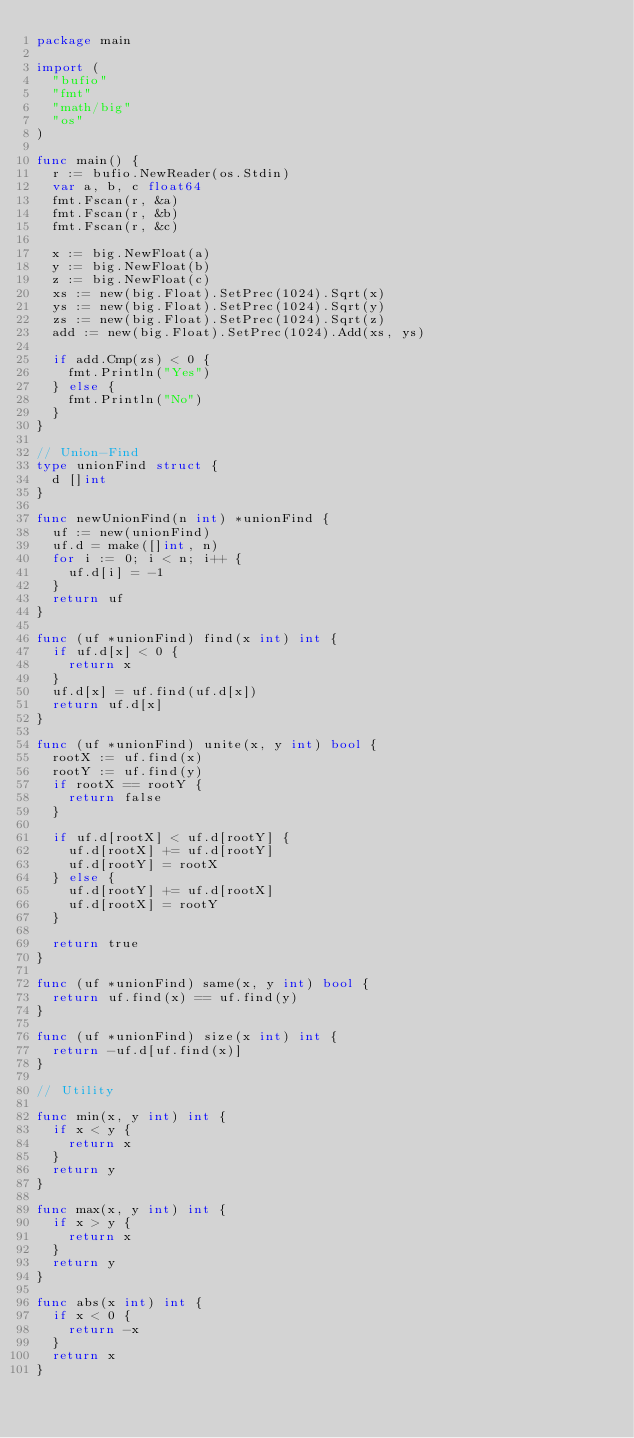Convert code to text. <code><loc_0><loc_0><loc_500><loc_500><_Go_>package main

import (
	"bufio"
	"fmt"
	"math/big"
	"os"
)

func main() {
	r := bufio.NewReader(os.Stdin)
	var a, b, c float64
	fmt.Fscan(r, &a)
	fmt.Fscan(r, &b)
	fmt.Fscan(r, &c)

	x := big.NewFloat(a)
	y := big.NewFloat(b)
	z := big.NewFloat(c)
	xs := new(big.Float).SetPrec(1024).Sqrt(x)
	ys := new(big.Float).SetPrec(1024).Sqrt(y)
	zs := new(big.Float).SetPrec(1024).Sqrt(z)
	add := new(big.Float).SetPrec(1024).Add(xs, ys)

	if add.Cmp(zs) < 0 {
		fmt.Println("Yes")
	} else {
		fmt.Println("No")
	}
}

// Union-Find
type unionFind struct {
	d []int
}

func newUnionFind(n int) *unionFind {
	uf := new(unionFind)
	uf.d = make([]int, n)
	for i := 0; i < n; i++ {
		uf.d[i] = -1
	}
	return uf
}

func (uf *unionFind) find(x int) int {
	if uf.d[x] < 0 {
		return x
	}
	uf.d[x] = uf.find(uf.d[x])
	return uf.d[x]
}

func (uf *unionFind) unite(x, y int) bool {
	rootX := uf.find(x)
	rootY := uf.find(y)
	if rootX == rootY {
		return false
	}

	if uf.d[rootX] < uf.d[rootY] {
		uf.d[rootX] += uf.d[rootY]
		uf.d[rootY] = rootX
	} else {
		uf.d[rootY] += uf.d[rootX]
		uf.d[rootX] = rootY
	}

	return true
}

func (uf *unionFind) same(x, y int) bool {
	return uf.find(x) == uf.find(y)
}

func (uf *unionFind) size(x int) int {
	return -uf.d[uf.find(x)]
}

// Utility

func min(x, y int) int {
	if x < y {
		return x
	}
	return y
}

func max(x, y int) int {
	if x > y {
		return x
	}
	return y
}

func abs(x int) int {
	if x < 0 {
		return -x
	}
	return x
}
</code> 